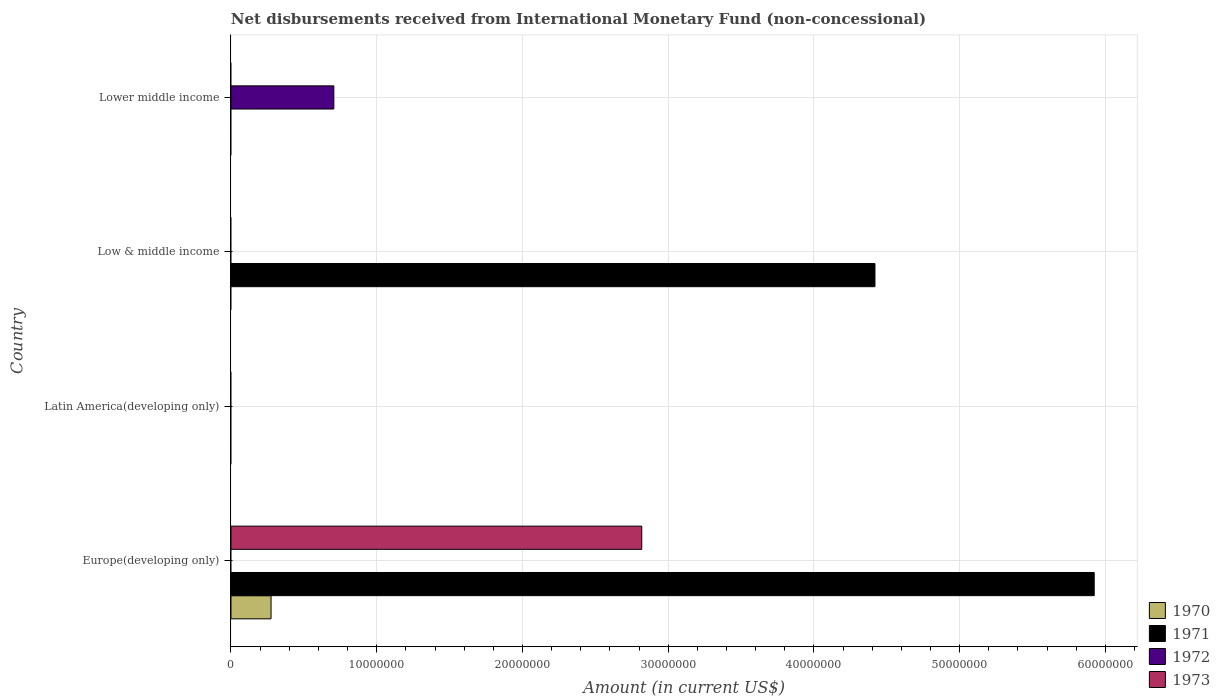Are the number of bars per tick equal to the number of legend labels?
Keep it short and to the point. No. Are the number of bars on each tick of the Y-axis equal?
Offer a very short reply. No. What is the label of the 1st group of bars from the top?
Your response must be concise. Lower middle income. Across all countries, what is the maximum amount of disbursements received from International Monetary Fund in 1973?
Provide a succinct answer. 2.82e+07. In which country was the amount of disbursements received from International Monetary Fund in 1970 maximum?
Provide a short and direct response. Europe(developing only). What is the total amount of disbursements received from International Monetary Fund in 1971 in the graph?
Your response must be concise. 1.03e+08. What is the difference between the amount of disbursements received from International Monetary Fund in 1971 in Europe(developing only) and the amount of disbursements received from International Monetary Fund in 1970 in Low & middle income?
Ensure brevity in your answer.  5.92e+07. What is the average amount of disbursements received from International Monetary Fund in 1972 per country?
Ensure brevity in your answer.  1.76e+06. What is the difference between the amount of disbursements received from International Monetary Fund in 1973 and amount of disbursements received from International Monetary Fund in 1971 in Europe(developing only)?
Offer a terse response. -3.10e+07. Is the amount of disbursements received from International Monetary Fund in 1971 in Europe(developing only) less than that in Low & middle income?
Keep it short and to the point. No. What is the difference between the highest and the lowest amount of disbursements received from International Monetary Fund in 1973?
Your answer should be very brief. 2.82e+07. In how many countries, is the amount of disbursements received from International Monetary Fund in 1972 greater than the average amount of disbursements received from International Monetary Fund in 1972 taken over all countries?
Provide a short and direct response. 1. Is it the case that in every country, the sum of the amount of disbursements received from International Monetary Fund in 1970 and amount of disbursements received from International Monetary Fund in 1971 is greater than the amount of disbursements received from International Monetary Fund in 1973?
Your answer should be very brief. No. What is the difference between two consecutive major ticks on the X-axis?
Provide a short and direct response. 1.00e+07. Where does the legend appear in the graph?
Provide a short and direct response. Bottom right. How many legend labels are there?
Your answer should be very brief. 4. What is the title of the graph?
Make the answer very short. Net disbursements received from International Monetary Fund (non-concessional). Does "1988" appear as one of the legend labels in the graph?
Your response must be concise. No. What is the label or title of the X-axis?
Ensure brevity in your answer.  Amount (in current US$). What is the Amount (in current US$) in 1970 in Europe(developing only)?
Provide a succinct answer. 2.75e+06. What is the Amount (in current US$) in 1971 in Europe(developing only)?
Keep it short and to the point. 5.92e+07. What is the Amount (in current US$) in 1972 in Europe(developing only)?
Offer a terse response. 0. What is the Amount (in current US$) in 1973 in Europe(developing only)?
Provide a short and direct response. 2.82e+07. What is the Amount (in current US$) of 1972 in Latin America(developing only)?
Provide a short and direct response. 0. What is the Amount (in current US$) in 1973 in Latin America(developing only)?
Give a very brief answer. 0. What is the Amount (in current US$) in 1970 in Low & middle income?
Ensure brevity in your answer.  0. What is the Amount (in current US$) in 1971 in Low & middle income?
Your response must be concise. 4.42e+07. What is the Amount (in current US$) of 1972 in Low & middle income?
Give a very brief answer. 0. What is the Amount (in current US$) in 1973 in Low & middle income?
Keep it short and to the point. 0. What is the Amount (in current US$) of 1970 in Lower middle income?
Your answer should be compact. 0. What is the Amount (in current US$) in 1972 in Lower middle income?
Provide a short and direct response. 7.06e+06. Across all countries, what is the maximum Amount (in current US$) of 1970?
Give a very brief answer. 2.75e+06. Across all countries, what is the maximum Amount (in current US$) in 1971?
Make the answer very short. 5.92e+07. Across all countries, what is the maximum Amount (in current US$) of 1972?
Your response must be concise. 7.06e+06. Across all countries, what is the maximum Amount (in current US$) in 1973?
Your response must be concise. 2.82e+07. Across all countries, what is the minimum Amount (in current US$) in 1971?
Ensure brevity in your answer.  0. Across all countries, what is the minimum Amount (in current US$) of 1973?
Give a very brief answer. 0. What is the total Amount (in current US$) in 1970 in the graph?
Provide a succinct answer. 2.75e+06. What is the total Amount (in current US$) of 1971 in the graph?
Your answer should be compact. 1.03e+08. What is the total Amount (in current US$) in 1972 in the graph?
Ensure brevity in your answer.  7.06e+06. What is the total Amount (in current US$) in 1973 in the graph?
Give a very brief answer. 2.82e+07. What is the difference between the Amount (in current US$) of 1971 in Europe(developing only) and that in Low & middle income?
Give a very brief answer. 1.50e+07. What is the difference between the Amount (in current US$) of 1970 in Europe(developing only) and the Amount (in current US$) of 1971 in Low & middle income?
Give a very brief answer. -4.14e+07. What is the difference between the Amount (in current US$) of 1970 in Europe(developing only) and the Amount (in current US$) of 1972 in Lower middle income?
Provide a short and direct response. -4.31e+06. What is the difference between the Amount (in current US$) of 1971 in Europe(developing only) and the Amount (in current US$) of 1972 in Lower middle income?
Your response must be concise. 5.22e+07. What is the difference between the Amount (in current US$) in 1971 in Low & middle income and the Amount (in current US$) in 1972 in Lower middle income?
Make the answer very short. 3.71e+07. What is the average Amount (in current US$) in 1970 per country?
Give a very brief answer. 6.88e+05. What is the average Amount (in current US$) of 1971 per country?
Ensure brevity in your answer.  2.59e+07. What is the average Amount (in current US$) of 1972 per country?
Offer a terse response. 1.76e+06. What is the average Amount (in current US$) of 1973 per country?
Offer a very short reply. 7.05e+06. What is the difference between the Amount (in current US$) in 1970 and Amount (in current US$) in 1971 in Europe(developing only)?
Give a very brief answer. -5.65e+07. What is the difference between the Amount (in current US$) in 1970 and Amount (in current US$) in 1973 in Europe(developing only)?
Provide a succinct answer. -2.54e+07. What is the difference between the Amount (in current US$) of 1971 and Amount (in current US$) of 1973 in Europe(developing only)?
Make the answer very short. 3.10e+07. What is the ratio of the Amount (in current US$) in 1971 in Europe(developing only) to that in Low & middle income?
Your response must be concise. 1.34. What is the difference between the highest and the lowest Amount (in current US$) in 1970?
Ensure brevity in your answer.  2.75e+06. What is the difference between the highest and the lowest Amount (in current US$) of 1971?
Make the answer very short. 5.92e+07. What is the difference between the highest and the lowest Amount (in current US$) in 1972?
Ensure brevity in your answer.  7.06e+06. What is the difference between the highest and the lowest Amount (in current US$) of 1973?
Your answer should be very brief. 2.82e+07. 